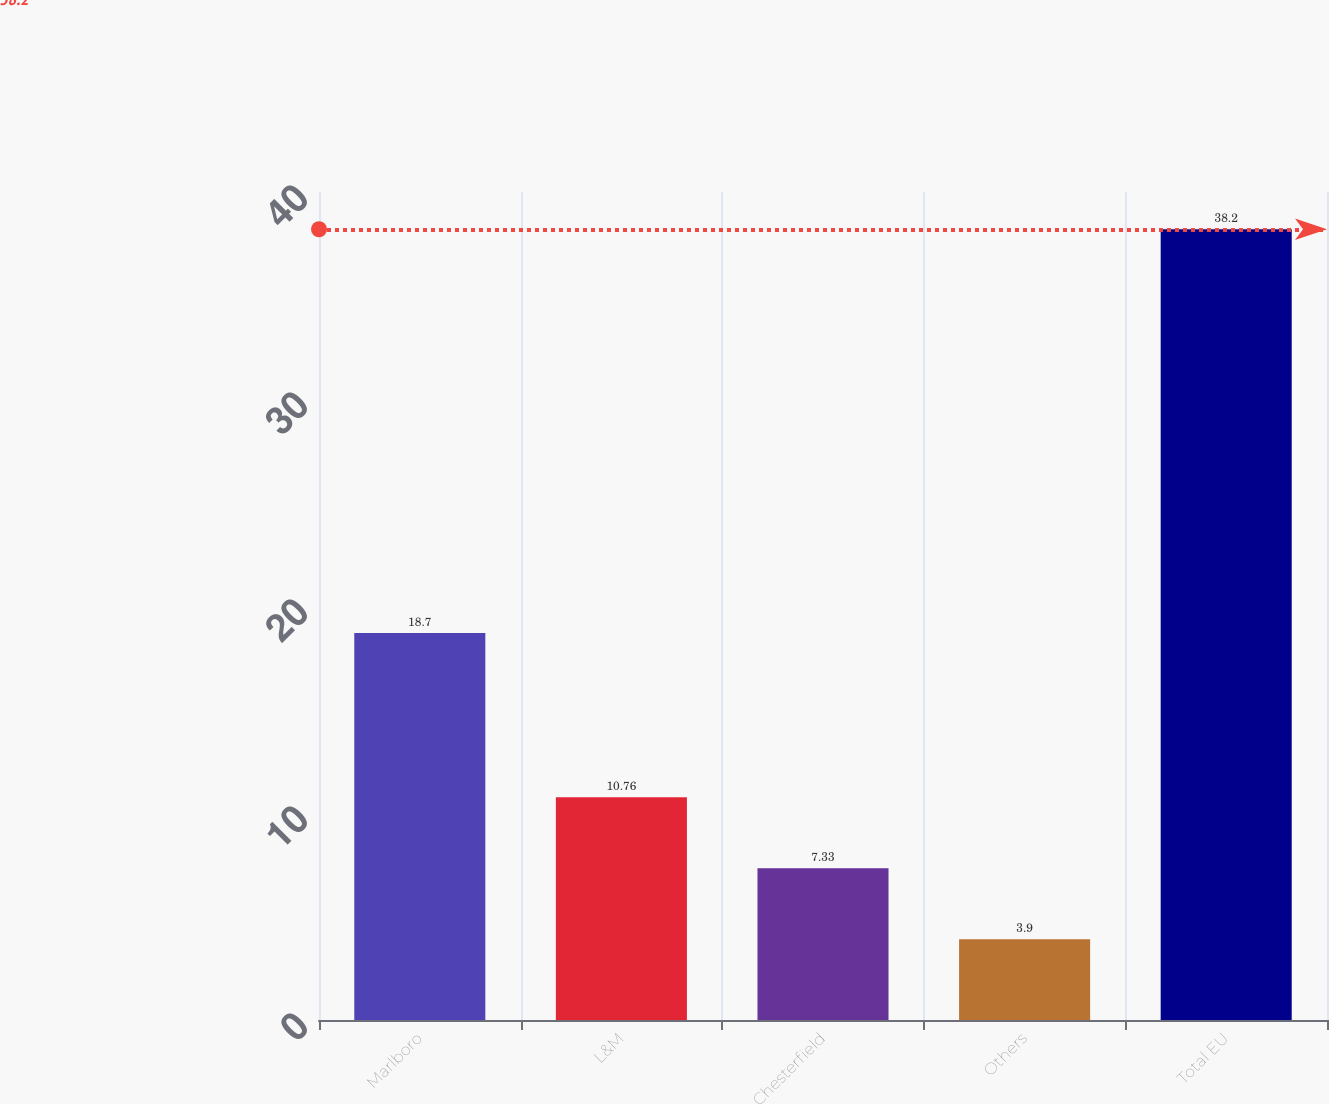Convert chart to OTSL. <chart><loc_0><loc_0><loc_500><loc_500><bar_chart><fcel>Marlboro<fcel>L&M<fcel>Chesterfield<fcel>Others<fcel>Total EU<nl><fcel>18.7<fcel>10.76<fcel>7.33<fcel>3.9<fcel>38.2<nl></chart> 